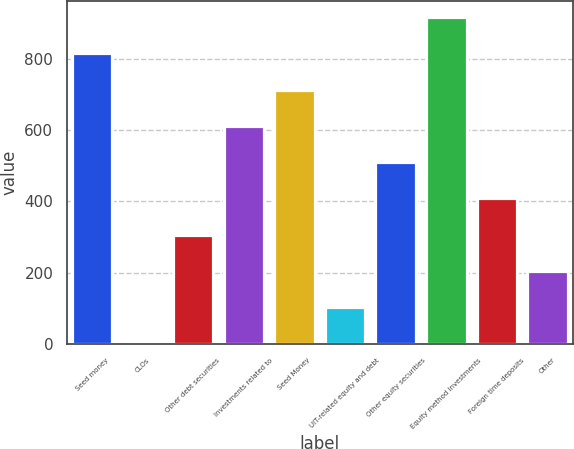Convert chart. <chart><loc_0><loc_0><loc_500><loc_500><bar_chart><fcel>Seed money<fcel>CLOs<fcel>Other debt securities<fcel>Investments related to<fcel>Seed Money<fcel>UIT-related equity and debt<fcel>Other equity securities<fcel>Equity method investments<fcel>Foreign time deposits<fcel>Other<nl><fcel>815.56<fcel>1.4<fcel>306.71<fcel>612.02<fcel>713.79<fcel>103.17<fcel>510.25<fcel>917.33<fcel>408.48<fcel>204.94<nl></chart> 